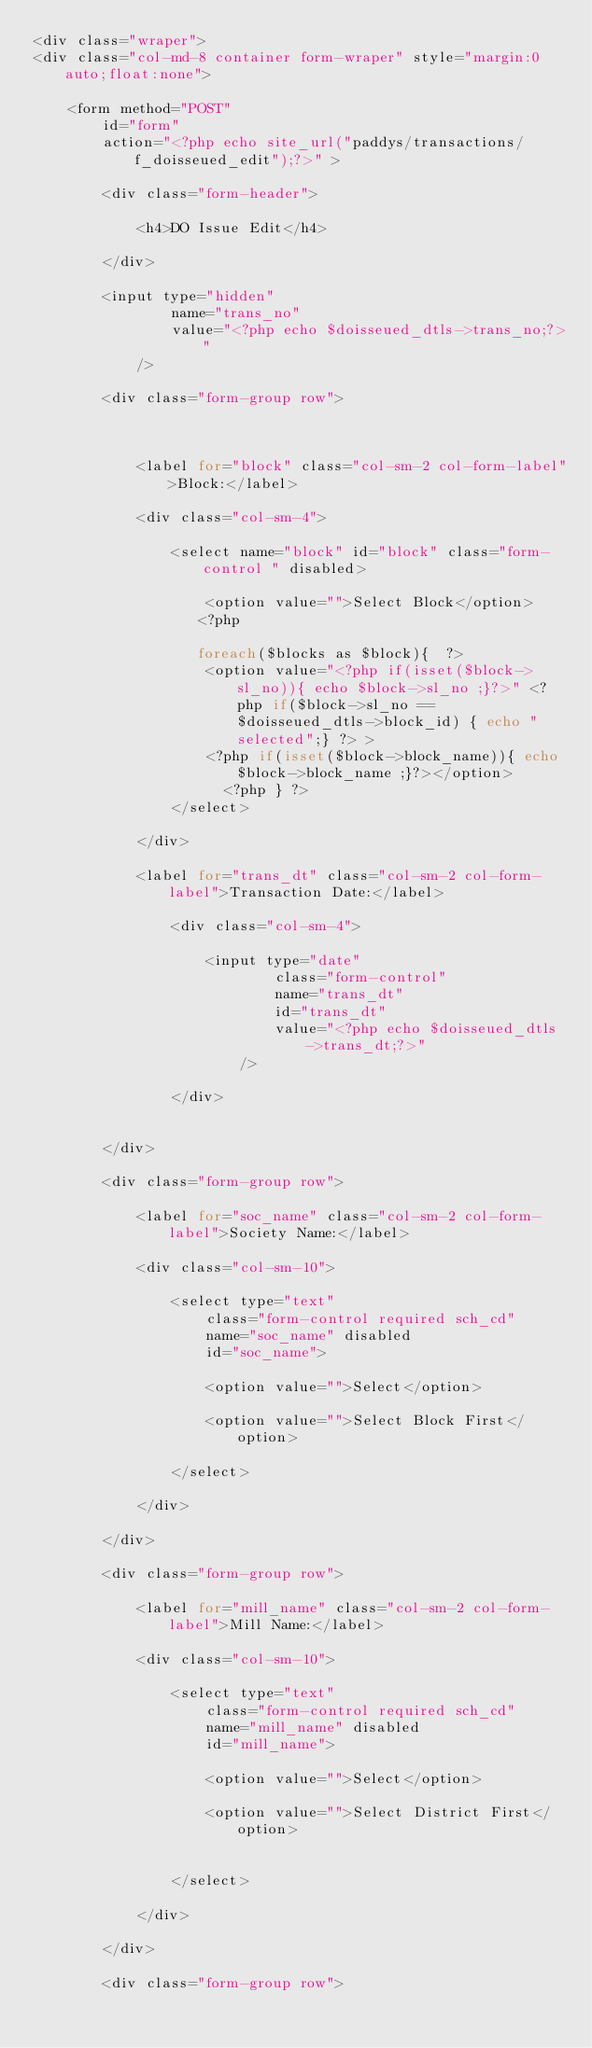Convert code to text. <code><loc_0><loc_0><loc_500><loc_500><_PHP_><div class="wraper">      
<div class="col-md-8 container form-wraper" style="margin:0 auto;float:none">

    <form method="POST" 
        id="form"
        action="<?php echo site_url("paddys/transactions/f_doisseued_edit");?>" >

        <div class="form-header">
        
            <h4>DO Issue Edit</h4>
        
        </div>

        <input type="hidden"
                name="trans_no"
                value="<?php echo $doisseued_dtls->trans_no;?>"
            />

        <div class="form-group row">

           

            <label for="block" class="col-sm-2 col-form-label">Block:</label>

            <div class="col-sm-4">

                <select name="block" id="block" class="form-control " disabled>

                    <option value="">Select Block</option>    
                   <?php 

                   foreach($blocks as $block){  ?>
                    <option value="<?php if(isset($block->sl_no)){ echo $block->sl_no ;}?>" <?php if($block->sl_no == $doisseued_dtls->block_id) { echo "selected";} ?> >
                    <?php if(isset($block->block_name)){ echo $block->block_name ;}?></option>    
                      <?php } ?>
                </select>

            </div>

            <label for="trans_dt" class="col-sm-2 col-form-label">Transaction Date:</label>

                <div class="col-sm-4">

                    <input type="date"
                            class="form-control" 
                            name="trans_dt"
                            id="trans_dt"
                            value="<?php echo $doisseued_dtls->trans_dt;?>"
                        />

                </div>


        </div>

        <div class="form-group row">

            <label for="soc_name" class="col-sm-2 col-form-label">Society Name:</label>

            <div class="col-sm-10">

                <select type="text"
                    class="form-control required sch_cd"
                    name="soc_name" disabled
                    id="soc_name">

                    <option value="">Select</option>    

                    <option value="">Select Block First</option>    

                </select>    

            </div>

        </div>  

        <div class="form-group row">

            <label for="mill_name" class="col-sm-2 col-form-label">Mill Name:</label>

            <div class="col-sm-10">

                <select type="text"
                    class="form-control required sch_cd"
                    name="mill_name" disabled
                    id="mill_name">

                    <option value="">Select</option>    

                    <option value="">Select District First</option>    


                </select>

            </div>

        </div>  

        <div class="form-group row">
</code> 